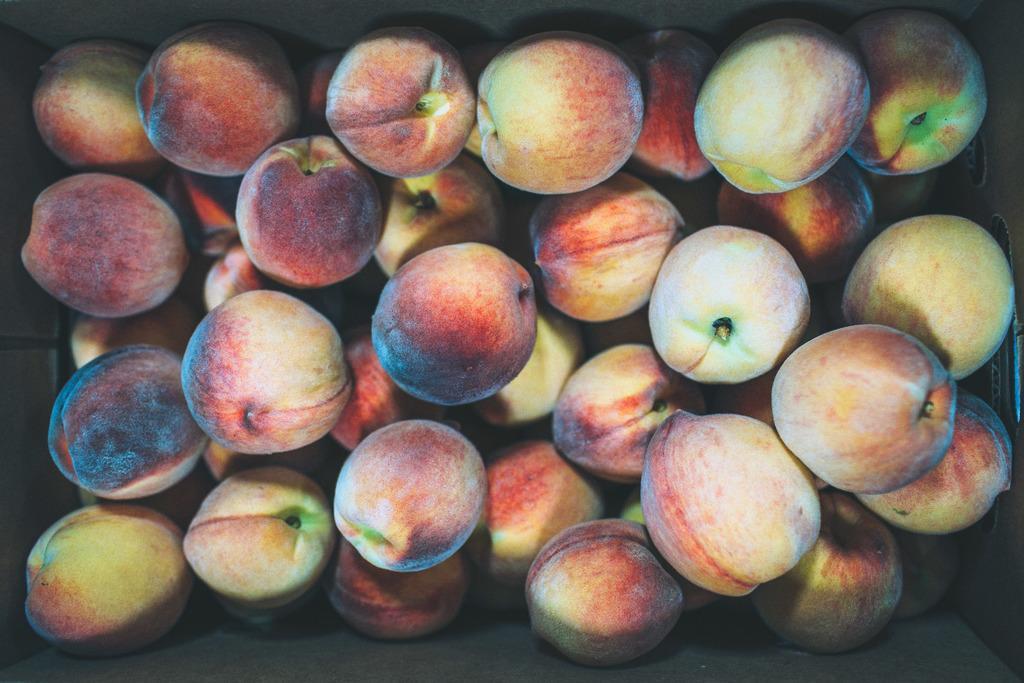How would you summarize this image in a sentence or two? In this image I see a number of peaches which are of red and green in color. 